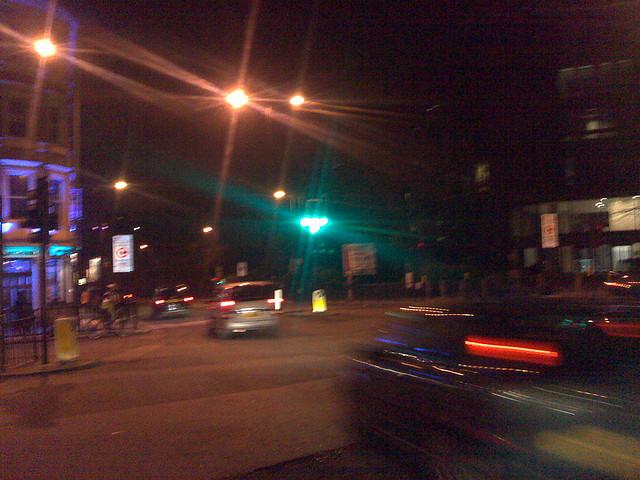Is the truck moving?
Write a very short answer. Yes. Is it night time?
Concise answer only. Yes. Are the street lights on?
Concise answer only. Yes. 